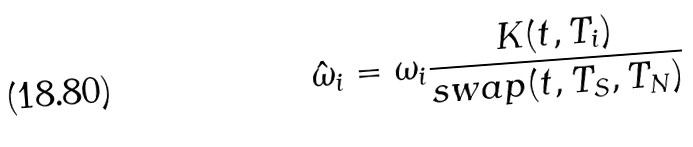Convert formula to latex. <formula><loc_0><loc_0><loc_500><loc_500>\hat { \omega } _ { i } = \omega _ { i } \frac { K ( t , T _ { i } ) } { s w a p ( t , T _ { S } , T _ { N } ) }</formula> 